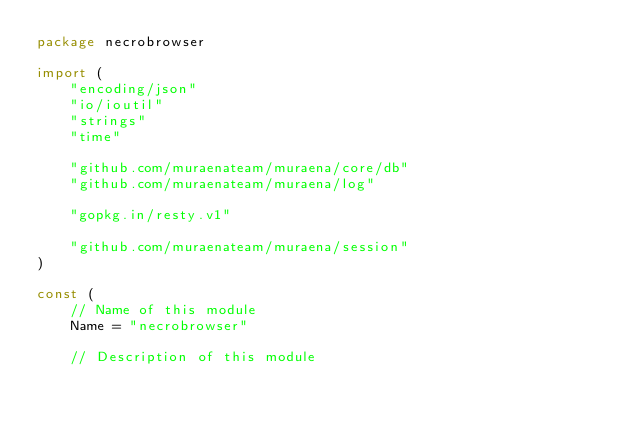Convert code to text. <code><loc_0><loc_0><loc_500><loc_500><_Go_>package necrobrowser

import (
	"encoding/json"
	"io/ioutil"
	"strings"
	"time"

	"github.com/muraenateam/muraena/core/db"
	"github.com/muraenateam/muraena/log"

	"gopkg.in/resty.v1"

	"github.com/muraenateam/muraena/session"
)

const (
	// Name of this module
	Name = "necrobrowser"

	// Description of this module</code> 